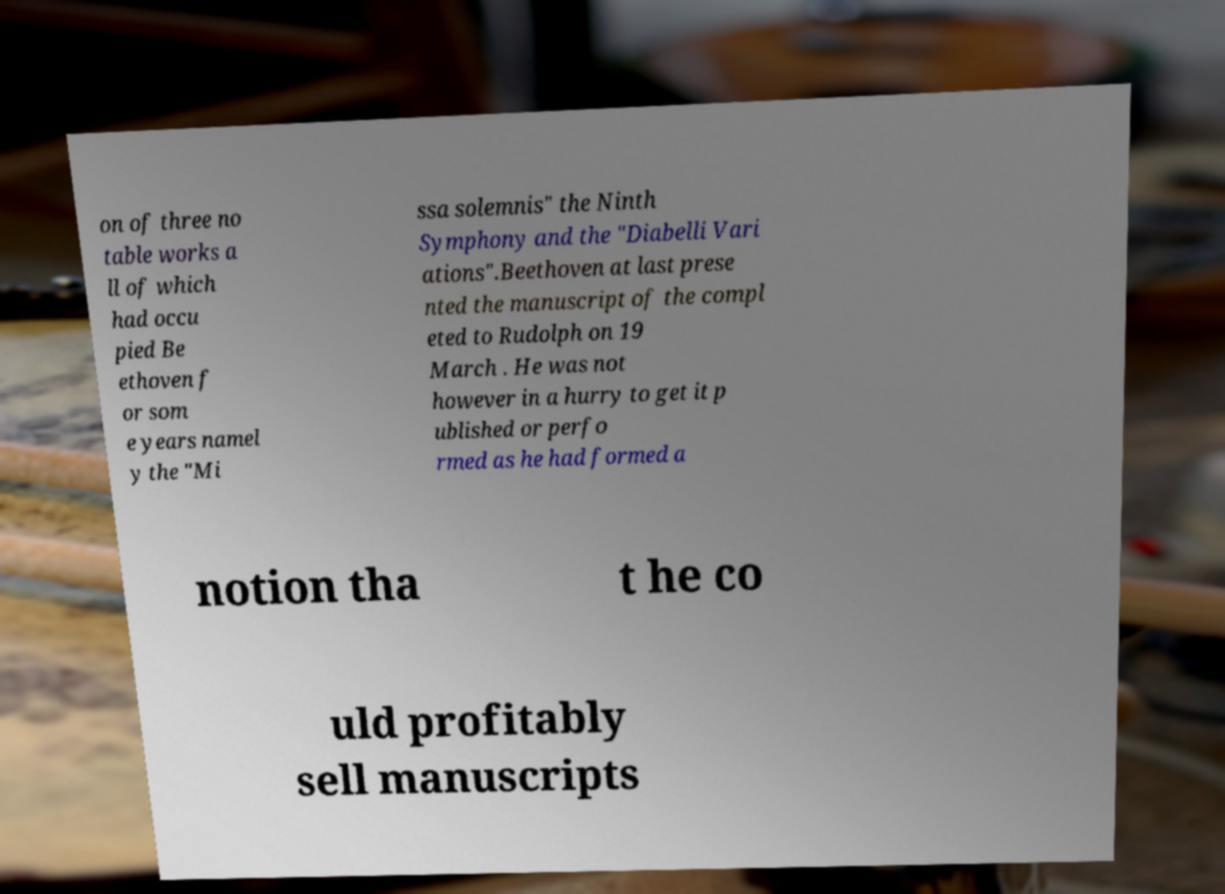There's text embedded in this image that I need extracted. Can you transcribe it verbatim? on of three no table works a ll of which had occu pied Be ethoven f or som e years namel y the "Mi ssa solemnis" the Ninth Symphony and the "Diabelli Vari ations".Beethoven at last prese nted the manuscript of the compl eted to Rudolph on 19 March . He was not however in a hurry to get it p ublished or perfo rmed as he had formed a notion tha t he co uld profitably sell manuscripts 